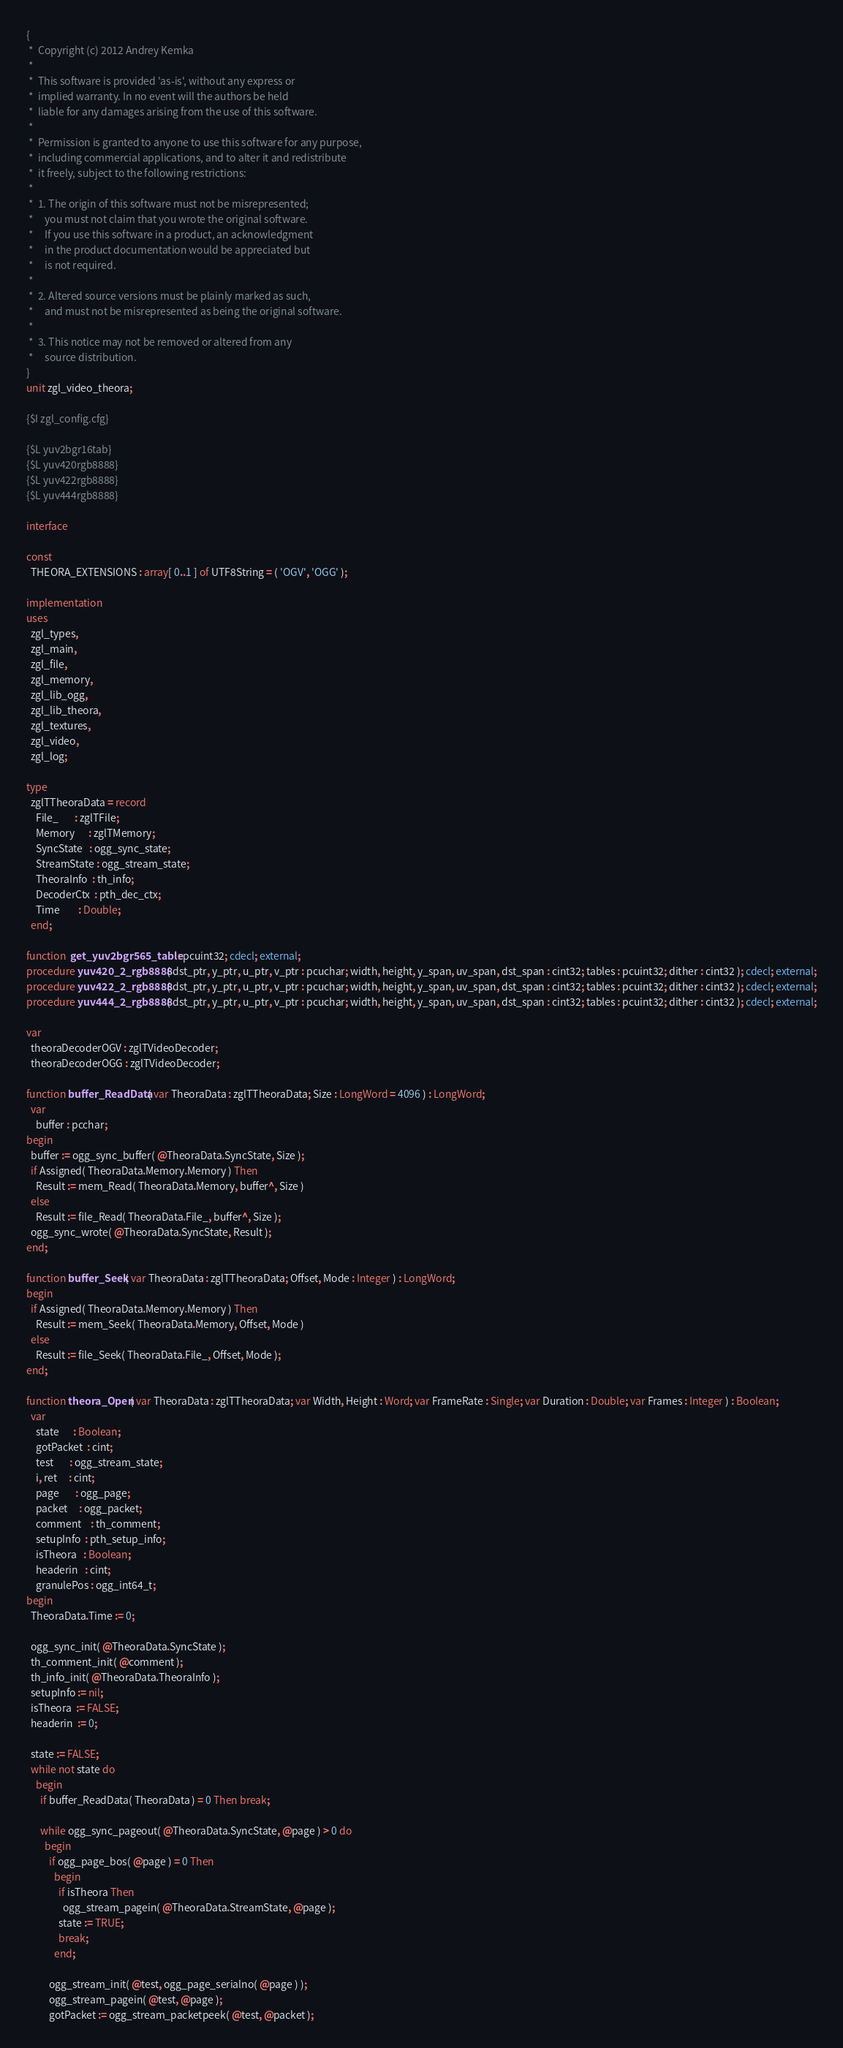Convert code to text. <code><loc_0><loc_0><loc_500><loc_500><_Pascal_>{
 *  Copyright (c) 2012 Andrey Kemka
 *
 *  This software is provided 'as-is', without any express or
 *  implied warranty. In no event will the authors be held
 *  liable for any damages arising from the use of this software.
 *
 *  Permission is granted to anyone to use this software for any purpose,
 *  including commercial applications, and to alter it and redistribute
 *  it freely, subject to the following restrictions:
 *
 *  1. The origin of this software must not be misrepresented;
 *     you must not claim that you wrote the original software.
 *     If you use this software in a product, an acknowledgment
 *     in the product documentation would be appreciated but
 *     is not required.
 *
 *  2. Altered source versions must be plainly marked as such,
 *     and must not be misrepresented as being the original software.
 *
 *  3. This notice may not be removed or altered from any
 *     source distribution.
}
unit zgl_video_theora;

{$I zgl_config.cfg}

{$L yuv2bgr16tab}
{$L yuv420rgb8888}
{$L yuv422rgb8888}
{$L yuv444rgb8888}

interface

const
  THEORA_EXTENSIONS : array[ 0..1 ] of UTF8String = ( 'OGV', 'OGG' );

implementation
uses
  zgl_types,
  zgl_main,
  zgl_file,
  zgl_memory,
  zgl_lib_ogg,
  zgl_lib_theora,
  zgl_textures,
  zgl_video,
  zgl_log;

type
  zglTTheoraData = record
    File_       : zglTFile;
    Memory      : zglTMemory;
    SyncState   : ogg_sync_state;
    StreamState : ogg_stream_state;
    TheoraInfo  : th_info;
    DecoderCtx  : pth_dec_ctx;
    Time        : Double;
  end;

function  get_yuv2bgr565_table : pcuint32; cdecl; external;
procedure yuv420_2_rgb8888( dst_ptr, y_ptr, u_ptr, v_ptr : pcuchar; width, height, y_span, uv_span, dst_span : cint32; tables : pcuint32; dither : cint32 ); cdecl; external;
procedure yuv422_2_rgb8888( dst_ptr, y_ptr, u_ptr, v_ptr : pcuchar; width, height, y_span, uv_span, dst_span : cint32; tables : pcuint32; dither : cint32 ); cdecl; external;
procedure yuv444_2_rgb8888( dst_ptr, y_ptr, u_ptr, v_ptr : pcuchar; width, height, y_span, uv_span, dst_span : cint32; tables : pcuint32; dither : cint32 ); cdecl; external;

var
  theoraDecoderOGV : zglTVideoDecoder;
  theoraDecoderOGG : zglTVideoDecoder;

function buffer_ReadData( var TheoraData : zglTTheoraData; Size : LongWord = 4096 ) : LongWord;
  var
    buffer : pcchar;
begin
  buffer := ogg_sync_buffer( @TheoraData.SyncState, Size );
  if Assigned( TheoraData.Memory.Memory ) Then
    Result := mem_Read( TheoraData.Memory, buffer^, Size )
  else
    Result := file_Read( TheoraData.File_, buffer^, Size );
  ogg_sync_wrote( @TheoraData.SyncState, Result );
end;

function buffer_Seek( var TheoraData : zglTTheoraData; Offset, Mode : Integer ) : LongWord;
begin
  if Assigned( TheoraData.Memory.Memory ) Then
    Result := mem_Seek( TheoraData.Memory, Offset, Mode )
  else
    Result := file_Seek( TheoraData.File_, Offset, Mode );
end;

function theora_Open( var TheoraData : zglTTheoraData; var Width, Height : Word; var FrameRate : Single; var Duration : Double; var Frames : Integer ) : Boolean;
  var
    state      : Boolean;
    gotPacket  : cint;
    test       : ogg_stream_state;
    i, ret     : cint;
    page       : ogg_page;
    packet     : ogg_packet;
    comment    : th_comment;
    setupInfo  : pth_setup_info;
    isTheora   : Boolean;
    headerin   : cint;
    granulePos : ogg_int64_t;
begin
  TheoraData.Time := 0;

  ogg_sync_init( @TheoraData.SyncState );
  th_comment_init( @comment );
  th_info_init( @TheoraData.TheoraInfo );
  setupInfo := nil;
  isTheora  := FALSE;
  headerin  := 0;

  state := FALSE;
  while not state do
    begin
      if buffer_ReadData( TheoraData ) = 0 Then break;

      while ogg_sync_pageout( @TheoraData.SyncState, @page ) > 0 do
        begin
          if ogg_page_bos( @page ) = 0 Then
            begin
              if isTheora Then
                ogg_stream_pagein( @TheoraData.StreamState, @page );
              state := TRUE;
              break;
            end;

          ogg_stream_init( @test, ogg_page_serialno( @page ) );
          ogg_stream_pagein( @test, @page );
          gotPacket := ogg_stream_packetpeek( @test, @packet );
</code> 